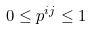<formula> <loc_0><loc_0><loc_500><loc_500>0 \leq p ^ { i j } \leq 1</formula> 